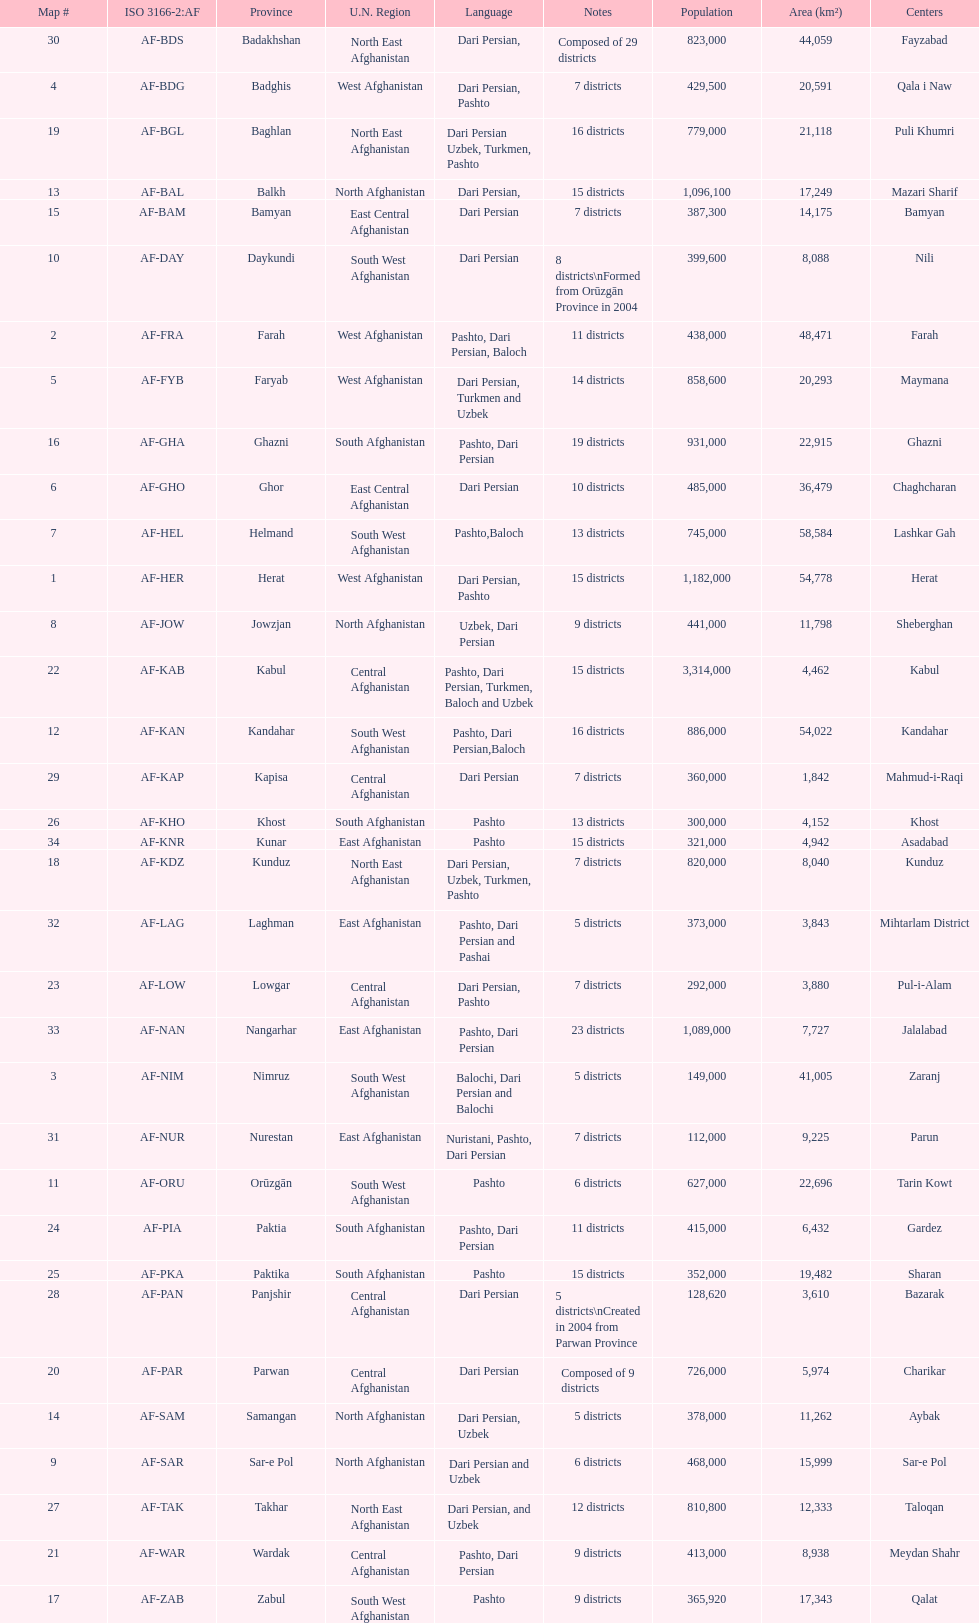How many provinces have pashto as one of their languages 20. 